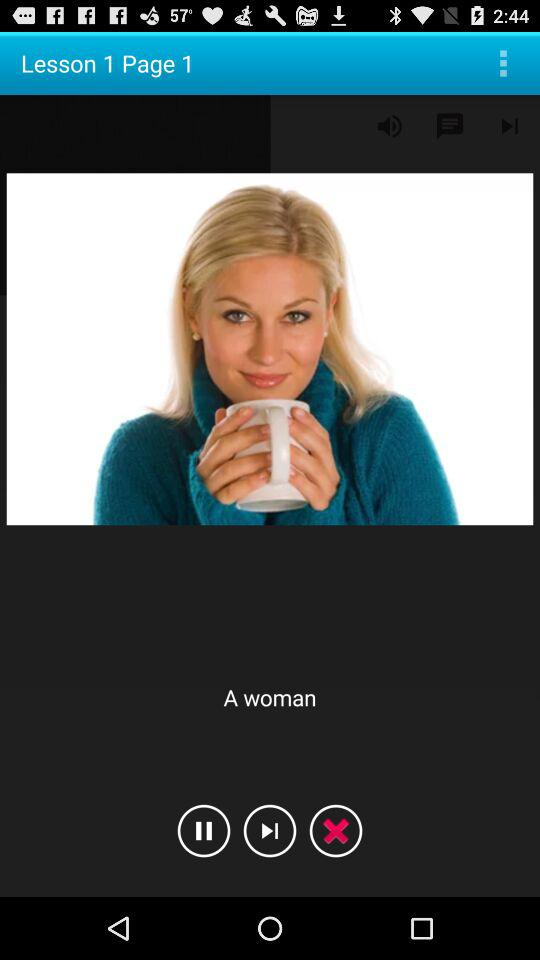What is the page number? The page number is 1. 